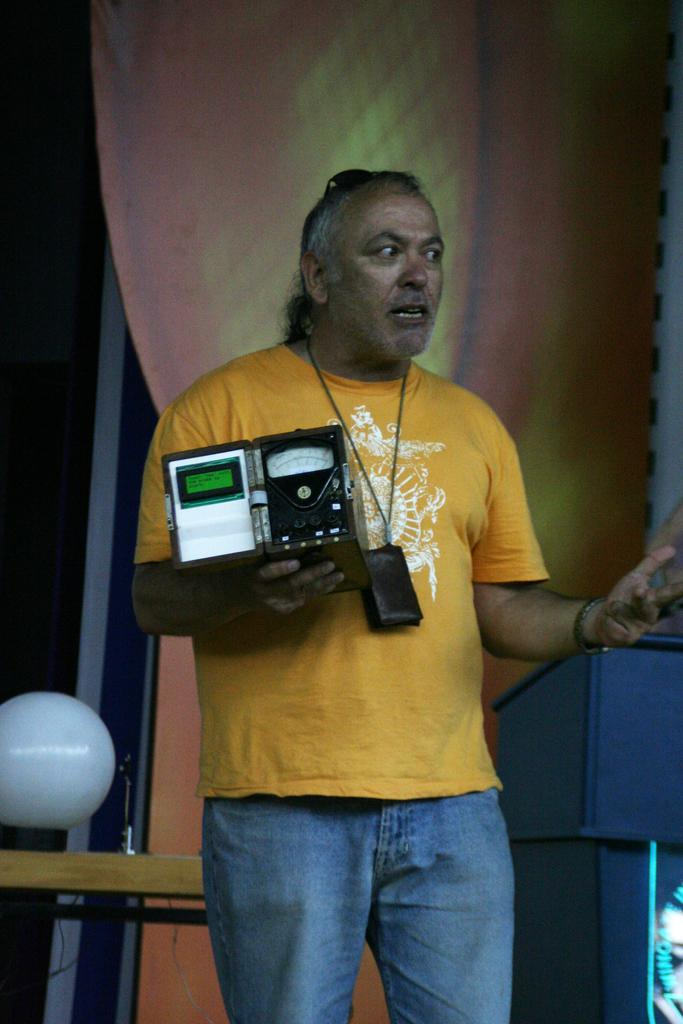What is the man in the image doing? The man is standing in the image. What is the man holding in the image? The man is holding an object. What can be seen on the left side of the image? There is a table on the left side of the image. What can be seen on the right side of the image? There is a podium on the right side of the image. What is visible in the background of the image? There is a curtain and a wall in the background of the image. What type of jewel is the man wearing on his head in the image? There is no jewel visible on the man's head in the image. 